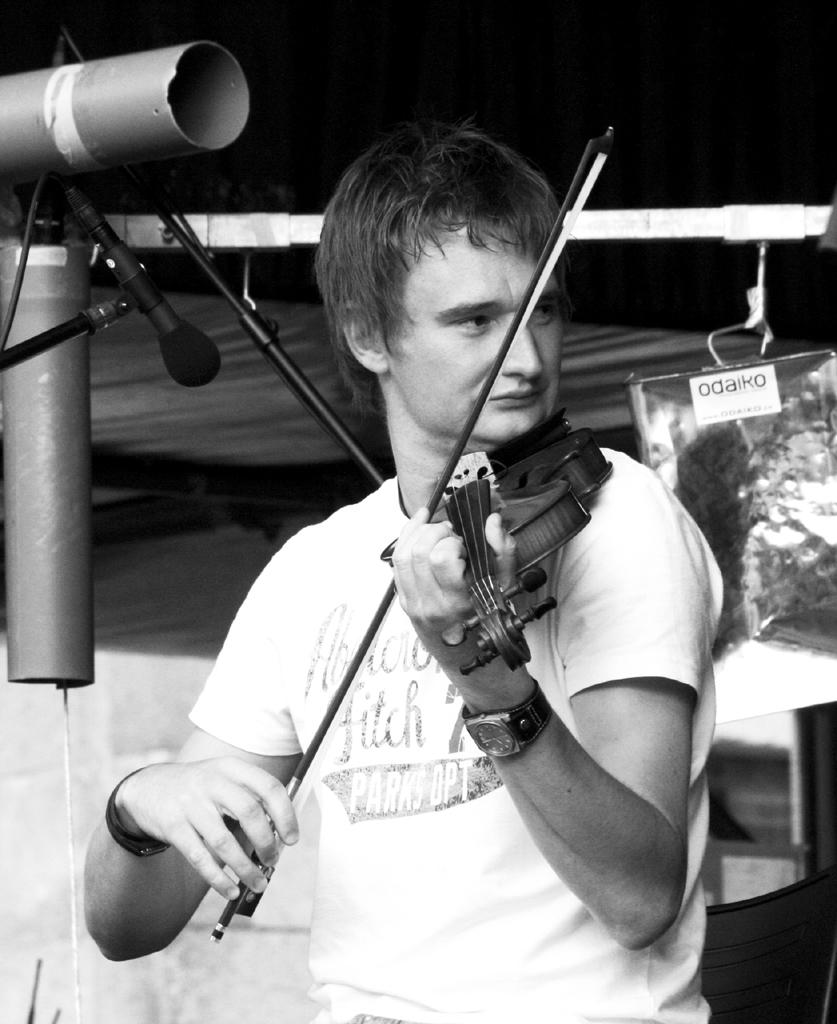What is the man in the image doing? The man is playing a violin in the image. What object is present on the left side of the image? There is a microphone on a stand on the left side of the image. What is the color scheme of the image? The image is black and white. What type of spark can be seen coming from the violin in the image? There is no spark coming from the violin in the image; it is a black and white image with no visible sparks. 